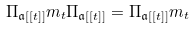Convert formula to latex. <formula><loc_0><loc_0><loc_500><loc_500>\Pi _ { \mathfrak { a } [ [ t ] ] } m _ { t } \Pi _ { \mathfrak { a } [ [ t ] ] } = \Pi _ { \mathfrak { a } [ [ t ] ] } m _ { t }</formula> 